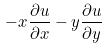Convert formula to latex. <formula><loc_0><loc_0><loc_500><loc_500>- x \frac { \partial u } { \partial x } - y \frac { \partial u } { \partial y }</formula> 